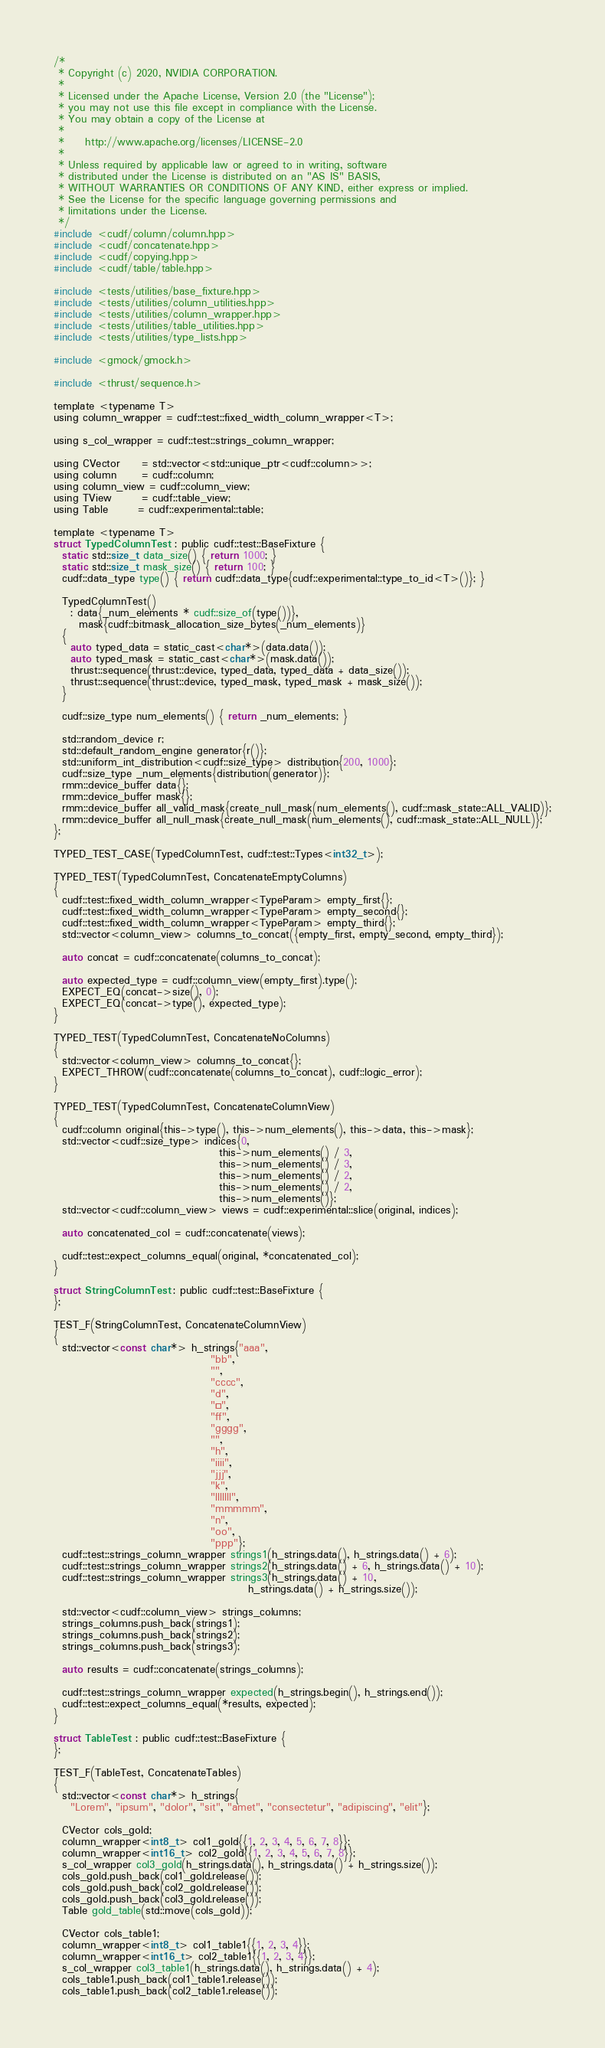Convert code to text. <code><loc_0><loc_0><loc_500><loc_500><_Cuda_>/*
 * Copyright (c) 2020, NVIDIA CORPORATION.
 *
 * Licensed under the Apache License, Version 2.0 (the "License");
 * you may not use this file except in compliance with the License.
 * You may obtain a copy of the License at
 *
 *     http://www.apache.org/licenses/LICENSE-2.0
 *
 * Unless required by applicable law or agreed to in writing, software
 * distributed under the License is distributed on an "AS IS" BASIS,
 * WITHOUT WARRANTIES OR CONDITIONS OF ANY KIND, either express or implied.
 * See the License for the specific language governing permissions and
 * limitations under the License.
 */
#include <cudf/column/column.hpp>
#include <cudf/concatenate.hpp>
#include <cudf/copying.hpp>
#include <cudf/table/table.hpp>

#include <tests/utilities/base_fixture.hpp>
#include <tests/utilities/column_utilities.hpp>
#include <tests/utilities/column_wrapper.hpp>
#include <tests/utilities/table_utilities.hpp>
#include <tests/utilities/type_lists.hpp>

#include <gmock/gmock.h>

#include <thrust/sequence.h>

template <typename T>
using column_wrapper = cudf::test::fixed_width_column_wrapper<T>;

using s_col_wrapper = cudf::test::strings_column_wrapper;

using CVector     = std::vector<std::unique_ptr<cudf::column>>;
using column      = cudf::column;
using column_view = cudf::column_view;
using TView       = cudf::table_view;
using Table       = cudf::experimental::table;

template <typename T>
struct TypedColumnTest : public cudf::test::BaseFixture {
  static std::size_t data_size() { return 1000; }
  static std::size_t mask_size() { return 100; }
  cudf::data_type type() { return cudf::data_type{cudf::experimental::type_to_id<T>()}; }

  TypedColumnTest()
    : data{_num_elements * cudf::size_of(type())},
      mask{cudf::bitmask_allocation_size_bytes(_num_elements)}
  {
    auto typed_data = static_cast<char*>(data.data());
    auto typed_mask = static_cast<char*>(mask.data());
    thrust::sequence(thrust::device, typed_data, typed_data + data_size());
    thrust::sequence(thrust::device, typed_mask, typed_mask + mask_size());
  }

  cudf::size_type num_elements() { return _num_elements; }

  std::random_device r;
  std::default_random_engine generator{r()};
  std::uniform_int_distribution<cudf::size_type> distribution{200, 1000};
  cudf::size_type _num_elements{distribution(generator)};
  rmm::device_buffer data{};
  rmm::device_buffer mask{};
  rmm::device_buffer all_valid_mask{create_null_mask(num_elements(), cudf::mask_state::ALL_VALID)};
  rmm::device_buffer all_null_mask{create_null_mask(num_elements(), cudf::mask_state::ALL_NULL)};
};

TYPED_TEST_CASE(TypedColumnTest, cudf::test::Types<int32_t>);

TYPED_TEST(TypedColumnTest, ConcatenateEmptyColumns)
{
  cudf::test::fixed_width_column_wrapper<TypeParam> empty_first{};
  cudf::test::fixed_width_column_wrapper<TypeParam> empty_second{};
  cudf::test::fixed_width_column_wrapper<TypeParam> empty_third{};
  std::vector<column_view> columns_to_concat({empty_first, empty_second, empty_third});

  auto concat = cudf::concatenate(columns_to_concat);

  auto expected_type = cudf::column_view(empty_first).type();
  EXPECT_EQ(concat->size(), 0);
  EXPECT_EQ(concat->type(), expected_type);
}

TYPED_TEST(TypedColumnTest, ConcatenateNoColumns)
{
  std::vector<column_view> columns_to_concat{};
  EXPECT_THROW(cudf::concatenate(columns_to_concat), cudf::logic_error);
}

TYPED_TEST(TypedColumnTest, ConcatenateColumnView)
{
  cudf::column original{this->type(), this->num_elements(), this->data, this->mask};
  std::vector<cudf::size_type> indices{0,
                                       this->num_elements() / 3,
                                       this->num_elements() / 3,
                                       this->num_elements() / 2,
                                       this->num_elements() / 2,
                                       this->num_elements()};
  std::vector<cudf::column_view> views = cudf::experimental::slice(original, indices);

  auto concatenated_col = cudf::concatenate(views);

  cudf::test::expect_columns_equal(original, *concatenated_col);
}

struct StringColumnTest : public cudf::test::BaseFixture {
};

TEST_F(StringColumnTest, ConcatenateColumnView)
{
  std::vector<const char*> h_strings{"aaa",
                                     "bb",
                                     "",
                                     "cccc",
                                     "d",
                                     "ééé",
                                     "ff",
                                     "gggg",
                                     "",
                                     "h",
                                     "iiii",
                                     "jjj",
                                     "k",
                                     "lllllll",
                                     "mmmmm",
                                     "n",
                                     "oo",
                                     "ppp"};
  cudf::test::strings_column_wrapper strings1(h_strings.data(), h_strings.data() + 6);
  cudf::test::strings_column_wrapper strings2(h_strings.data() + 6, h_strings.data() + 10);
  cudf::test::strings_column_wrapper strings3(h_strings.data() + 10,
                                              h_strings.data() + h_strings.size());

  std::vector<cudf::column_view> strings_columns;
  strings_columns.push_back(strings1);
  strings_columns.push_back(strings2);
  strings_columns.push_back(strings3);

  auto results = cudf::concatenate(strings_columns);

  cudf::test::strings_column_wrapper expected(h_strings.begin(), h_strings.end());
  cudf::test::expect_columns_equal(*results, expected);
}

struct TableTest : public cudf::test::BaseFixture {
};

TEST_F(TableTest, ConcatenateTables)
{
  std::vector<const char*> h_strings{
    "Lorem", "ipsum", "dolor", "sit", "amet", "consectetur", "adipiscing", "elit"};

  CVector cols_gold;
  column_wrapper<int8_t> col1_gold{{1, 2, 3, 4, 5, 6, 7, 8}};
  column_wrapper<int16_t> col2_gold{{1, 2, 3, 4, 5, 6, 7, 8}};
  s_col_wrapper col3_gold(h_strings.data(), h_strings.data() + h_strings.size());
  cols_gold.push_back(col1_gold.release());
  cols_gold.push_back(col2_gold.release());
  cols_gold.push_back(col3_gold.release());
  Table gold_table(std::move(cols_gold));

  CVector cols_table1;
  column_wrapper<int8_t> col1_table1{{1, 2, 3, 4}};
  column_wrapper<int16_t> col2_table1{{1, 2, 3, 4}};
  s_col_wrapper col3_table1(h_strings.data(), h_strings.data() + 4);
  cols_table1.push_back(col1_table1.release());
  cols_table1.push_back(col2_table1.release());</code> 